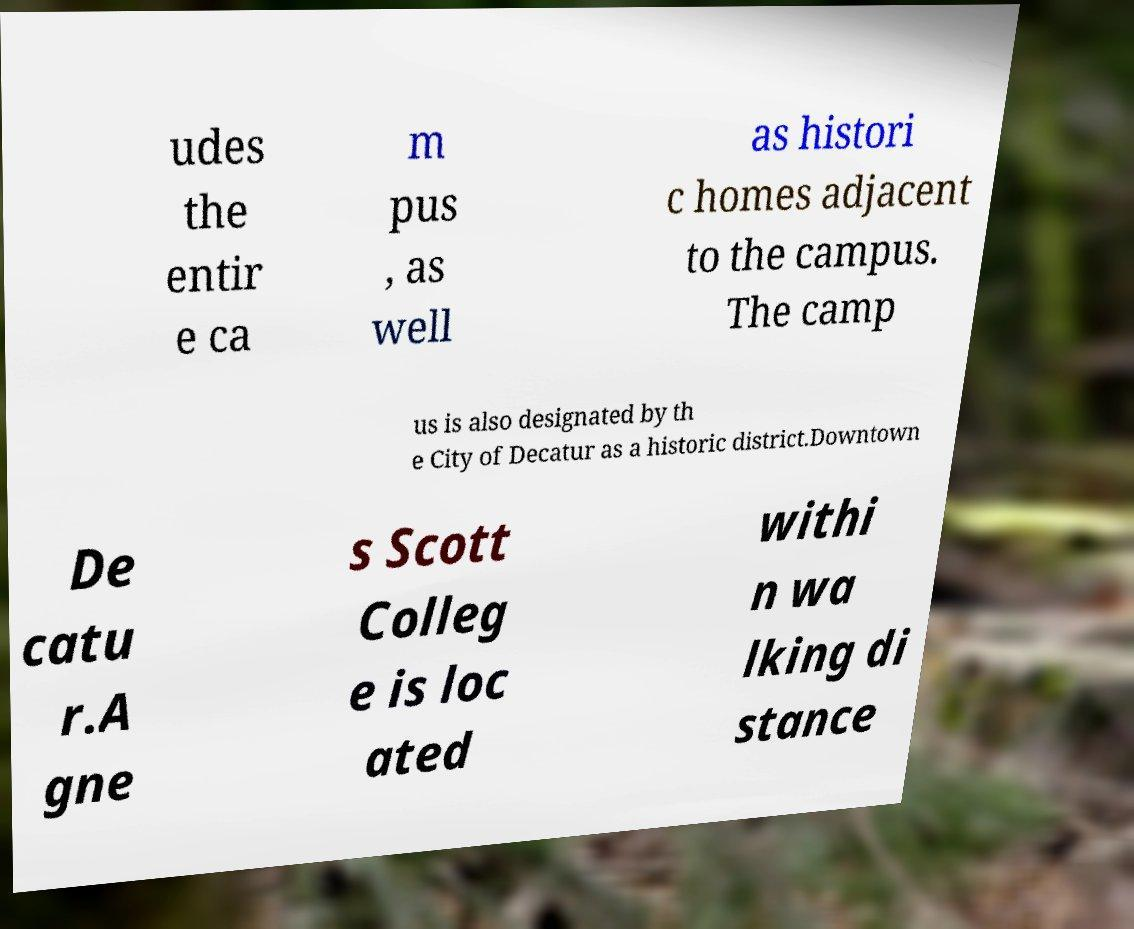There's text embedded in this image that I need extracted. Can you transcribe it verbatim? udes the entir e ca m pus , as well as histori c homes adjacent to the campus. The camp us is also designated by th e City of Decatur as a historic district.Downtown De catu r.A gne s Scott Colleg e is loc ated withi n wa lking di stance 